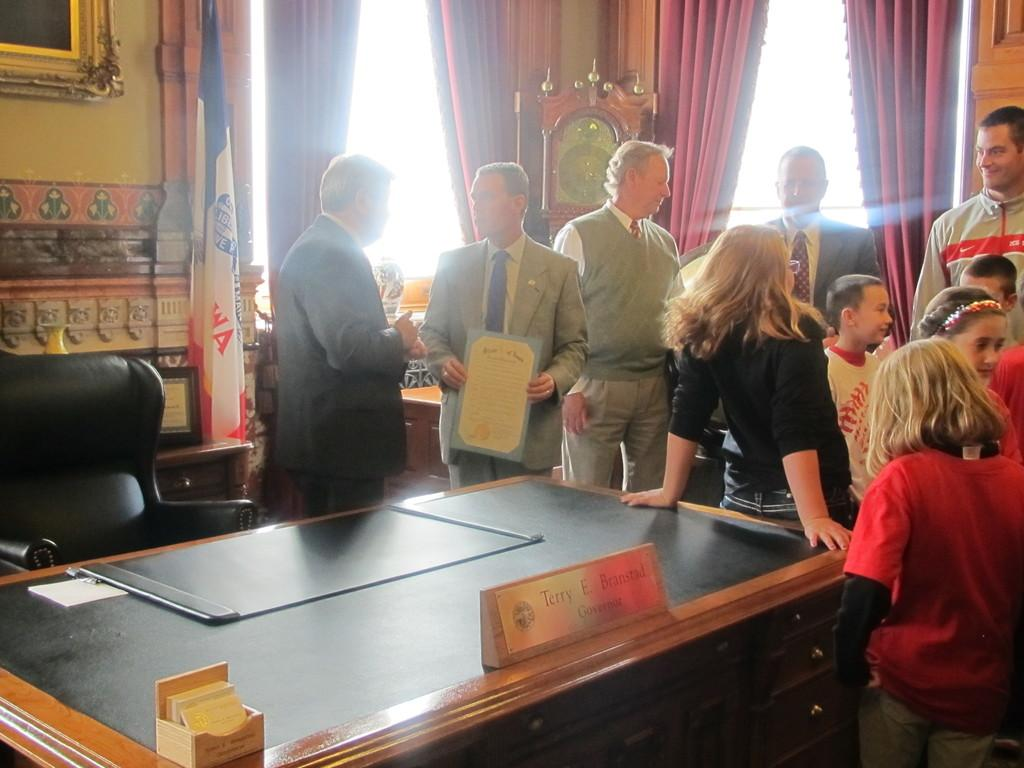How many people are in the image? There are people in the image, but the exact number is not specified. What are the people doing in the image? The people are standing and talking in the image. What is the facial expression of the people in the image? The people are smiling in the image. What type of furniture is present in the image? There is a table in the image. What is the setting of the image? The setting appears to be an office room. What color is the sofa in the image? There is no sofa present in the image. Can you see a hill in the background of the image? There is no hill visible in the image. 